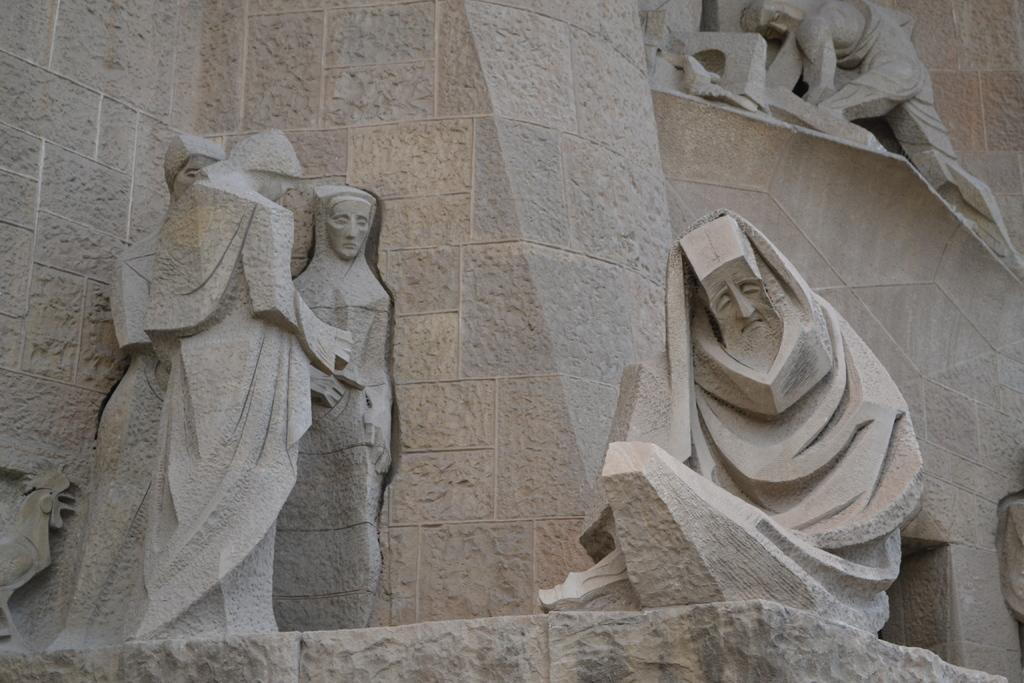What type of art is present in the image? There are sculptures in the image. What type of structure is visible in the image? There is a building in the image. What type of lamp is hanging from the ceiling in the image? There is no lamp present in the image; it only features sculptures and a building. What grade of chicken is being served in the image? There is no chicken present in the image. 